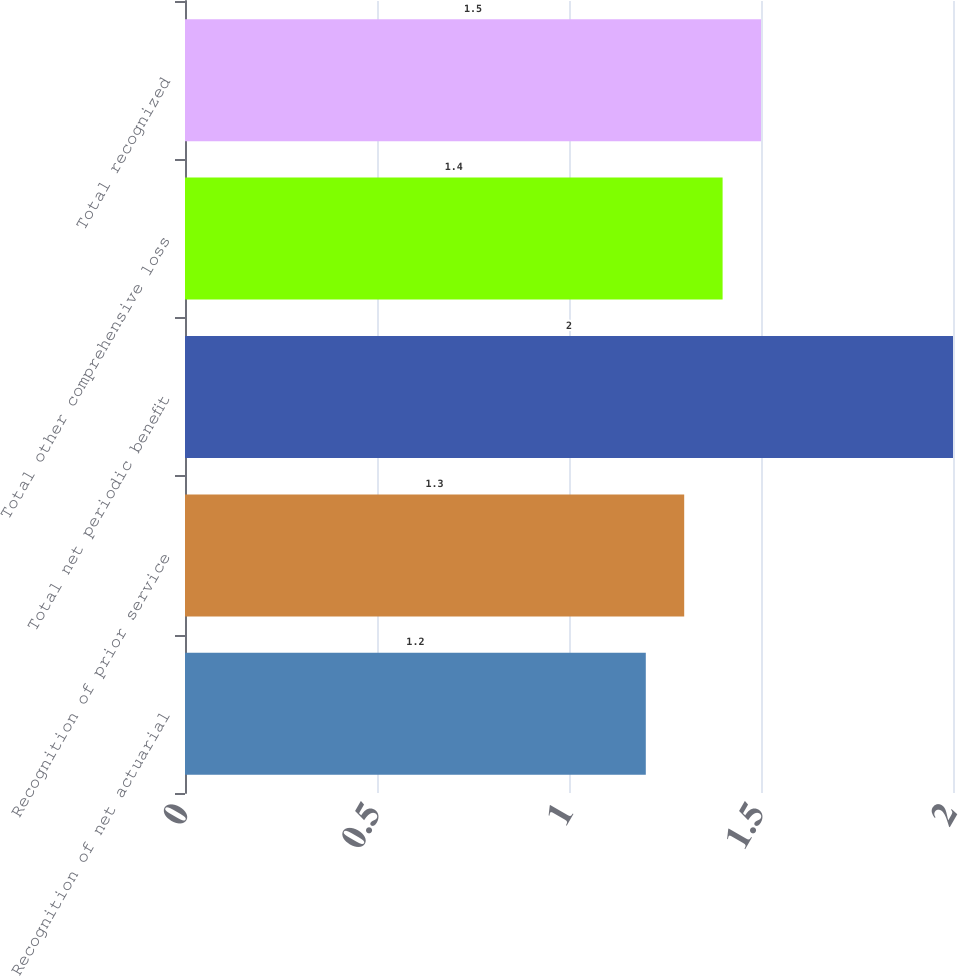<chart> <loc_0><loc_0><loc_500><loc_500><bar_chart><fcel>Recognition of net actuarial<fcel>Recognition of prior service<fcel>Total net periodic benefit<fcel>Total other comprehensive loss<fcel>Total recognized<nl><fcel>1.2<fcel>1.3<fcel>2<fcel>1.4<fcel>1.5<nl></chart> 